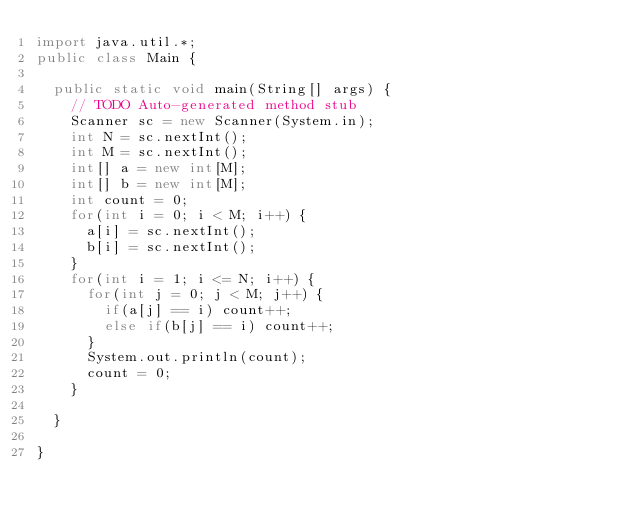<code> <loc_0><loc_0><loc_500><loc_500><_Java_>import java.util.*;
public class Main {

	public static void main(String[] args) {
		// TODO Auto-generated method stub
		Scanner sc = new Scanner(System.in);
		int N = sc.nextInt();
		int M = sc.nextInt();
		int[] a = new int[M];
		int[] b = new int[M];
		int count = 0;
		for(int i = 0; i < M; i++) {
			a[i] = sc.nextInt();
			b[i] = sc.nextInt();
		}
		for(int i = 1; i <= N; i++) {
			for(int j = 0; j < M; j++) {
				if(a[j] == i) count++;
				else if(b[j] == i) count++;
			}
			System.out.println(count);
			count = 0;
		}

	}

}
</code> 